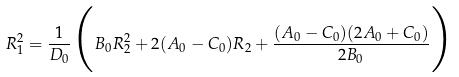<formula> <loc_0><loc_0><loc_500><loc_500>R _ { 1 } ^ { 2 } = \frac { 1 } { D _ { 0 } } \Big { ( } B _ { 0 } R _ { 2 } ^ { 2 } + 2 ( A _ { 0 } - C _ { 0 } ) R _ { 2 } + \frac { ( A _ { 0 } - C _ { 0 } ) ( 2 A _ { 0 } + C _ { 0 } ) } { 2 B _ { 0 } } \Big { ) }</formula> 